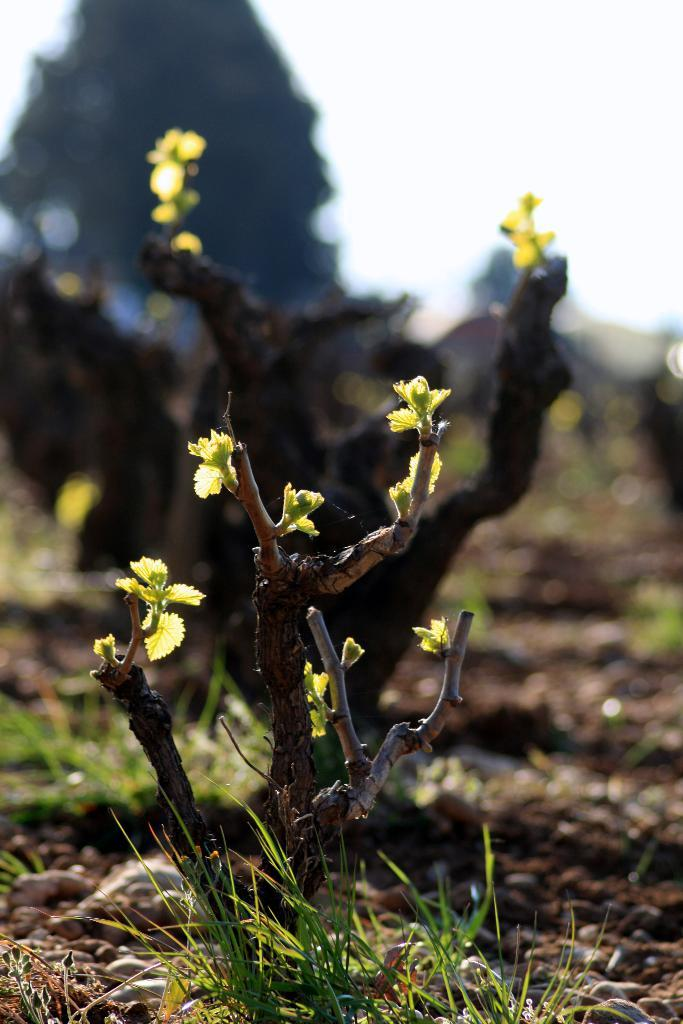What type of natural elements can be seen at the bottom of the image? There is grass and plants at the bottom of the image. What is the ground made of in the image? Soil is visible in the image. What other objects can be found in the image? Stones are present in the image. How would you describe the background of the image? The background of the image is blurry. What month is depicted in the image? There is no specific month depicted in the image; it does not contain any seasonal or time-related elements. 